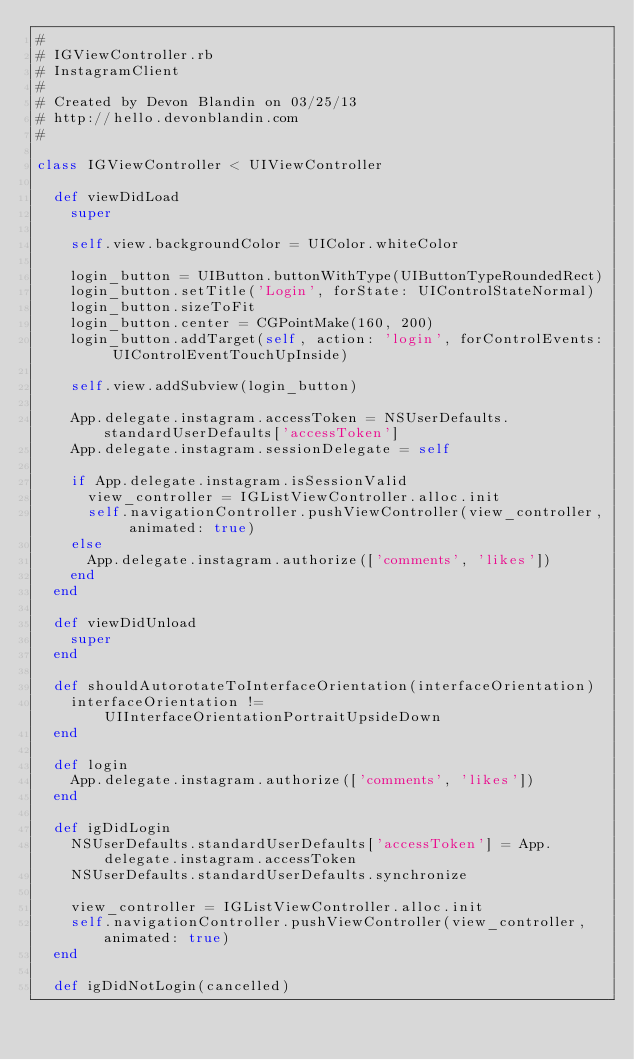<code> <loc_0><loc_0><loc_500><loc_500><_Ruby_>#
# IGViewController.rb
# InstagramClient
#
# Created by Devon Blandin on 03/25/13
# http://hello.devonblandin.com
#

class IGViewController < UIViewController

  def viewDidLoad
    super

    self.view.backgroundColor = UIColor.whiteColor

    login_button = UIButton.buttonWithType(UIButtonTypeRoundedRect)
    login_button.setTitle('Login', forState: UIControlStateNormal)
    login_button.sizeToFit
    login_button.center = CGPointMake(160, 200)
    login_button.addTarget(self, action: 'login', forControlEvents: UIControlEventTouchUpInside)

    self.view.addSubview(login_button)

    App.delegate.instagram.accessToken = NSUserDefaults.standardUserDefaults['accessToken']
    App.delegate.instagram.sessionDelegate = self

    if App.delegate.instagram.isSessionValid
      view_controller = IGListViewController.alloc.init
      self.navigationController.pushViewController(view_controller, animated: true)
    else
      App.delegate.instagram.authorize(['comments', 'likes'])
    end
  end

  def viewDidUnload
    super
  end

  def shouldAutorotateToInterfaceOrientation(interfaceOrientation)
    interfaceOrientation != UIInterfaceOrientationPortraitUpsideDown
  end

  def login
    App.delegate.instagram.authorize(['comments', 'likes'])
  end

  def igDidLogin
    NSUserDefaults.standardUserDefaults['accessToken'] = App.delegate.instagram.accessToken
    NSUserDefaults.standardUserDefaults.synchronize

    view_controller = IGListViewController.alloc.init
    self.navigationController.pushViewController(view_controller, animated: true)
  end

  def igDidNotLogin(cancelled)</code> 